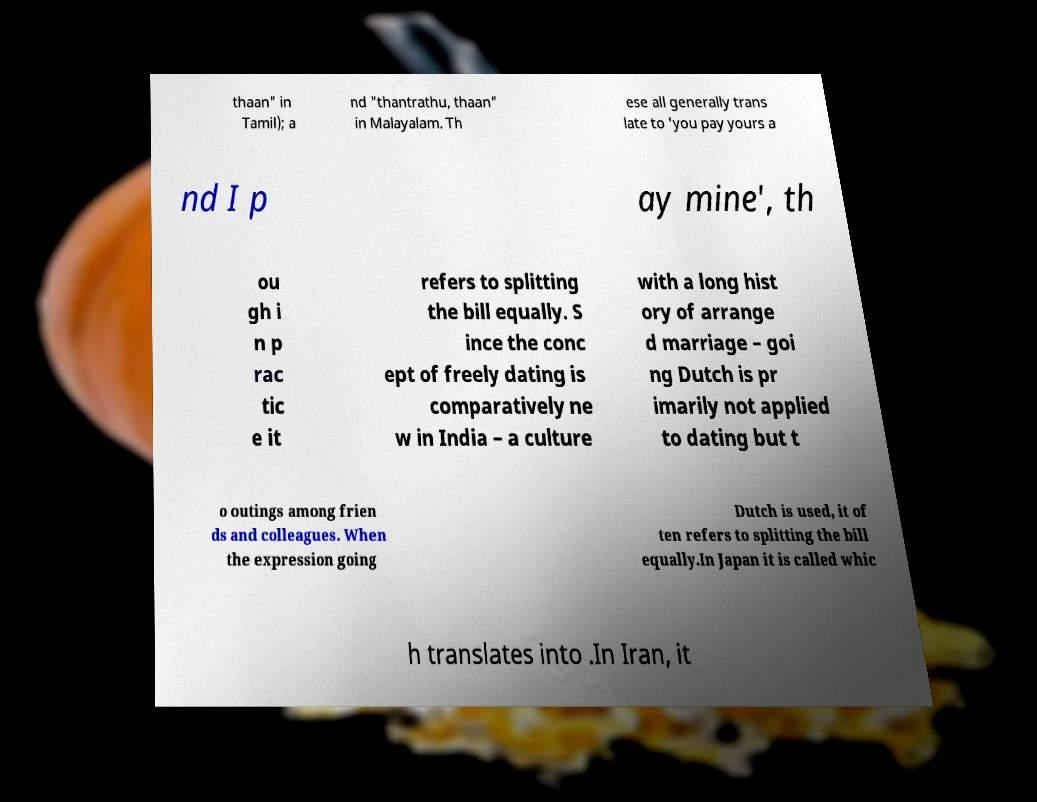Can you accurately transcribe the text from the provided image for me? thaan" in Tamil); a nd "thantrathu, thaan" in Malayalam. Th ese all generally trans late to 'you pay yours a nd I p ay mine', th ou gh i n p rac tic e it refers to splitting the bill equally. S ince the conc ept of freely dating is comparatively ne w in India – a culture with a long hist ory of arrange d marriage – goi ng Dutch is pr imarily not applied to dating but t o outings among frien ds and colleagues. When the expression going Dutch is used, it of ten refers to splitting the bill equally.In Japan it is called whic h translates into .In Iran, it 